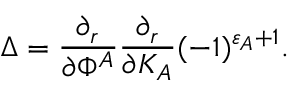<formula> <loc_0><loc_0><loc_500><loc_500>\Delta = { \frac { \partial _ { r } } { \partial \Phi ^ { A } } } { \frac { \partial _ { r } } { \partial K _ { A } } } ( - 1 ) ^ { \varepsilon _ { A } + 1 } .</formula> 